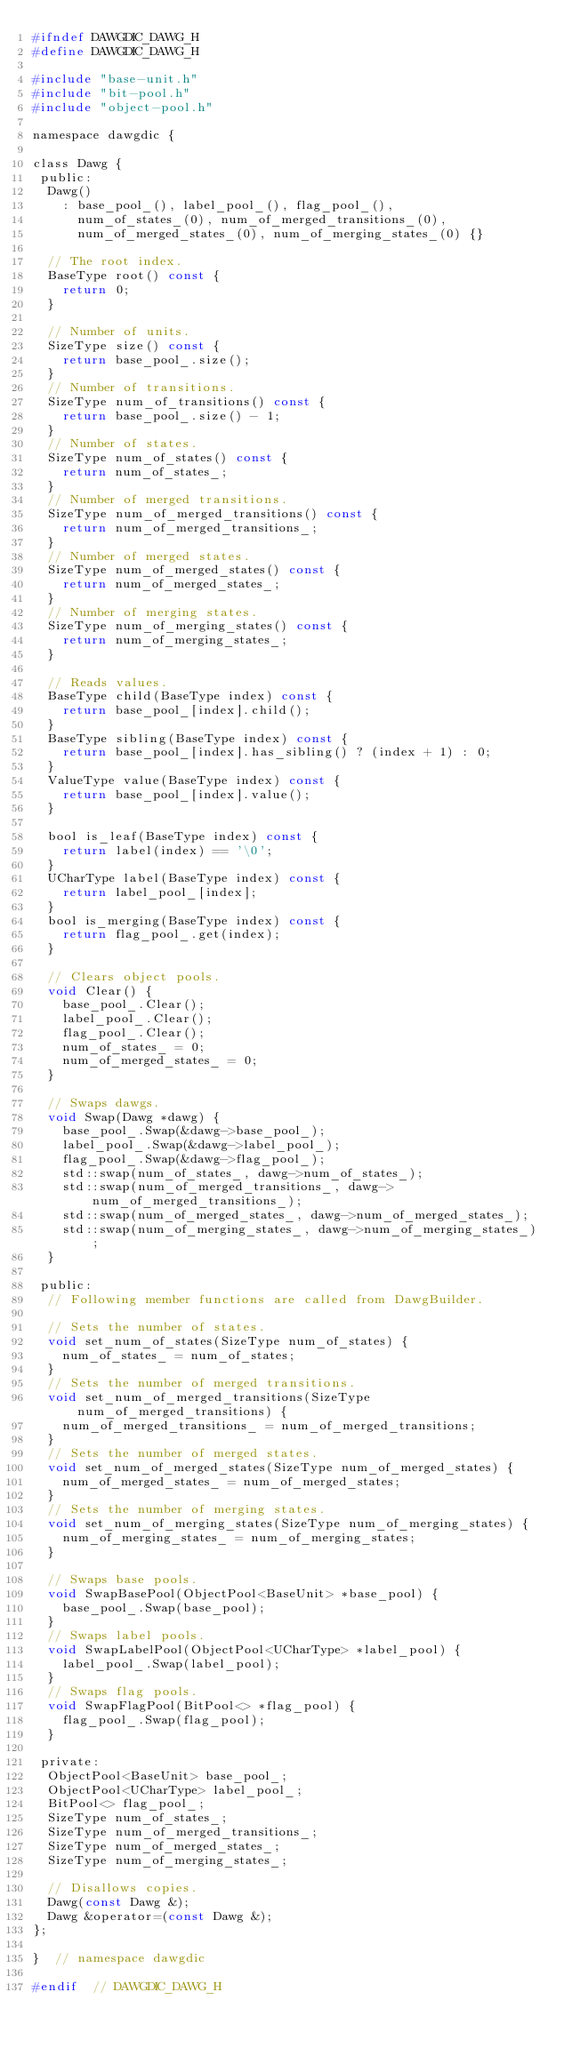<code> <loc_0><loc_0><loc_500><loc_500><_C_>#ifndef DAWGDIC_DAWG_H
#define DAWGDIC_DAWG_H

#include "base-unit.h"
#include "bit-pool.h"
#include "object-pool.h"

namespace dawgdic {

class Dawg {
 public:
  Dawg()
    : base_pool_(), label_pool_(), flag_pool_(),
      num_of_states_(0), num_of_merged_transitions_(0),
      num_of_merged_states_(0), num_of_merging_states_(0) {}

  // The root index.
  BaseType root() const {
    return 0;
  }

  // Number of units.
  SizeType size() const {
    return base_pool_.size();
  }
  // Number of transitions.
  SizeType num_of_transitions() const {
    return base_pool_.size() - 1;
  }
  // Number of states.
  SizeType num_of_states() const {
    return num_of_states_;
  }
  // Number of merged transitions.
  SizeType num_of_merged_transitions() const {
    return num_of_merged_transitions_;
  }
  // Number of merged states.
  SizeType num_of_merged_states() const {
    return num_of_merged_states_;
  }
  // Number of merging states.
  SizeType num_of_merging_states() const {
    return num_of_merging_states_;
  }

  // Reads values.
  BaseType child(BaseType index) const {
    return base_pool_[index].child();
  }
  BaseType sibling(BaseType index) const {
    return base_pool_[index].has_sibling() ? (index + 1) : 0;
  }
  ValueType value(BaseType index) const {
    return base_pool_[index].value();
  }

  bool is_leaf(BaseType index) const {
    return label(index) == '\0';
  }
  UCharType label(BaseType index) const {
    return label_pool_[index];
  }
  bool is_merging(BaseType index) const {
    return flag_pool_.get(index);
  }

  // Clears object pools.
  void Clear() {
    base_pool_.Clear();
    label_pool_.Clear();
    flag_pool_.Clear();
    num_of_states_ = 0;
    num_of_merged_states_ = 0;
  }

  // Swaps dawgs.
  void Swap(Dawg *dawg) {
    base_pool_.Swap(&dawg->base_pool_);
    label_pool_.Swap(&dawg->label_pool_);
    flag_pool_.Swap(&dawg->flag_pool_);
    std::swap(num_of_states_, dawg->num_of_states_);
    std::swap(num_of_merged_transitions_, dawg->num_of_merged_transitions_);
    std::swap(num_of_merged_states_, dawg->num_of_merged_states_);
    std::swap(num_of_merging_states_, dawg->num_of_merging_states_);
  }

 public:
  // Following member functions are called from DawgBuilder.

  // Sets the number of states.
  void set_num_of_states(SizeType num_of_states) {
    num_of_states_ = num_of_states;
  }
  // Sets the number of merged transitions.
  void set_num_of_merged_transitions(SizeType num_of_merged_transitions) {
    num_of_merged_transitions_ = num_of_merged_transitions;
  }
  // Sets the number of merged states.
  void set_num_of_merged_states(SizeType num_of_merged_states) {
    num_of_merged_states_ = num_of_merged_states;
  }
  // Sets the number of merging states.
  void set_num_of_merging_states(SizeType num_of_merging_states) {
    num_of_merging_states_ = num_of_merging_states;
  }

  // Swaps base pools.
  void SwapBasePool(ObjectPool<BaseUnit> *base_pool) {
    base_pool_.Swap(base_pool);
  }
  // Swaps label pools.
  void SwapLabelPool(ObjectPool<UCharType> *label_pool) {
    label_pool_.Swap(label_pool);
  }
  // Swaps flag pools.
  void SwapFlagPool(BitPool<> *flag_pool) {
    flag_pool_.Swap(flag_pool);
  }

 private:
  ObjectPool<BaseUnit> base_pool_;
  ObjectPool<UCharType> label_pool_;
  BitPool<> flag_pool_;
  SizeType num_of_states_;
  SizeType num_of_merged_transitions_;
  SizeType num_of_merged_states_;
  SizeType num_of_merging_states_;

  // Disallows copies.
  Dawg(const Dawg &);
  Dawg &operator=(const Dawg &);
};

}  // namespace dawgdic

#endif  // DAWGDIC_DAWG_H
</code> 